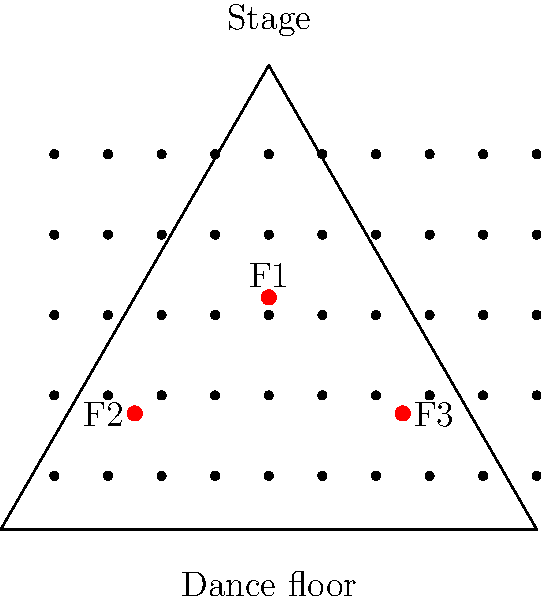In a triangular club space, you need to position three flashes (F1, F2, F3) to evenly illuminate a large group of club-goers without causing harsh shadows. Given the layout shown, what geometric principle should you apply to determine the optimal placement of the flashes, and how does this relate to the concept of the centroid? To optimize flash placement for even illumination without harsh shadows, we should consider the following steps:

1. Recognize that the club space is represented by an equilateral triangle, which has special geometric properties.

2. Recall that in an equilateral triangle, the centroid divides each median into two segments, with the segment closer to the vertex being twice the length of the segment closer to the midpoint of the opposite side.

3. The centroid is located at the intersection of all three medians, which are lines drawn from each vertex to the midpoint of the opposite side.

4. In this case, flash F1 is positioned at the centroid of the equilateral triangle.

5. Flashes F2 and F3 are positioned on the medians, specifically at the points that divide the medians in the ratio 1:2 (closer to the side than to the vertex).

6. This placement utilizes the principle of equidistance from the centroid to the sides of the triangle, ensuring that:
   a) Each flash covers a similar area of the dance floor.
   b) The overlapping coverage helps reduce harsh shadows.
   c) The elevated position of F1 provides overhead lighting, while F2 and F3 offer angled illumination.

7. The relationship to the centroid is crucial because:
   a) It's the balancing point of the triangle, ensuring equal distribution of light.
   b) It's equidistant from all sides, maximizing coverage efficiency.
   c) It divides the medians in a 2:1 ratio, which we use for optimal flash positioning.

8. This arrangement takes advantage of the geometric properties of the equilateral triangle to create a balanced, even lighting setup that minimizes harsh shadows by providing light from multiple angles.
Answer: Utilize the centroid and median division principle of an equilateral triangle for optimal flash placement. 